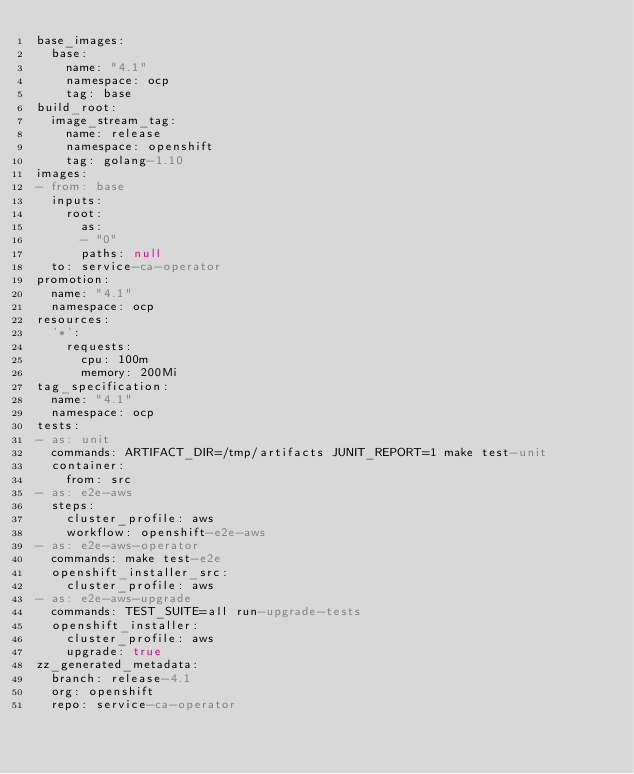Convert code to text. <code><loc_0><loc_0><loc_500><loc_500><_YAML_>base_images:
  base:
    name: "4.1"
    namespace: ocp
    tag: base
build_root:
  image_stream_tag:
    name: release
    namespace: openshift
    tag: golang-1.10
images:
- from: base
  inputs:
    root:
      as:
      - "0"
      paths: null
  to: service-ca-operator
promotion:
  name: "4.1"
  namespace: ocp
resources:
  '*':
    requests:
      cpu: 100m
      memory: 200Mi
tag_specification:
  name: "4.1"
  namespace: ocp
tests:
- as: unit
  commands: ARTIFACT_DIR=/tmp/artifacts JUNIT_REPORT=1 make test-unit
  container:
    from: src
- as: e2e-aws
  steps:
    cluster_profile: aws
    workflow: openshift-e2e-aws
- as: e2e-aws-operator
  commands: make test-e2e
  openshift_installer_src:
    cluster_profile: aws
- as: e2e-aws-upgrade
  commands: TEST_SUITE=all run-upgrade-tests
  openshift_installer:
    cluster_profile: aws
    upgrade: true
zz_generated_metadata:
  branch: release-4.1
  org: openshift
  repo: service-ca-operator
</code> 